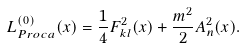Convert formula to latex. <formula><loc_0><loc_0><loc_500><loc_500>L ^ { ( 0 ) } _ { P r o c a } ( x ) = \frac { 1 } { 4 } F ^ { 2 } _ { k l } ( x ) + \frac { m ^ { 2 } } { 2 } A ^ { 2 } _ { n } ( x ) .</formula> 